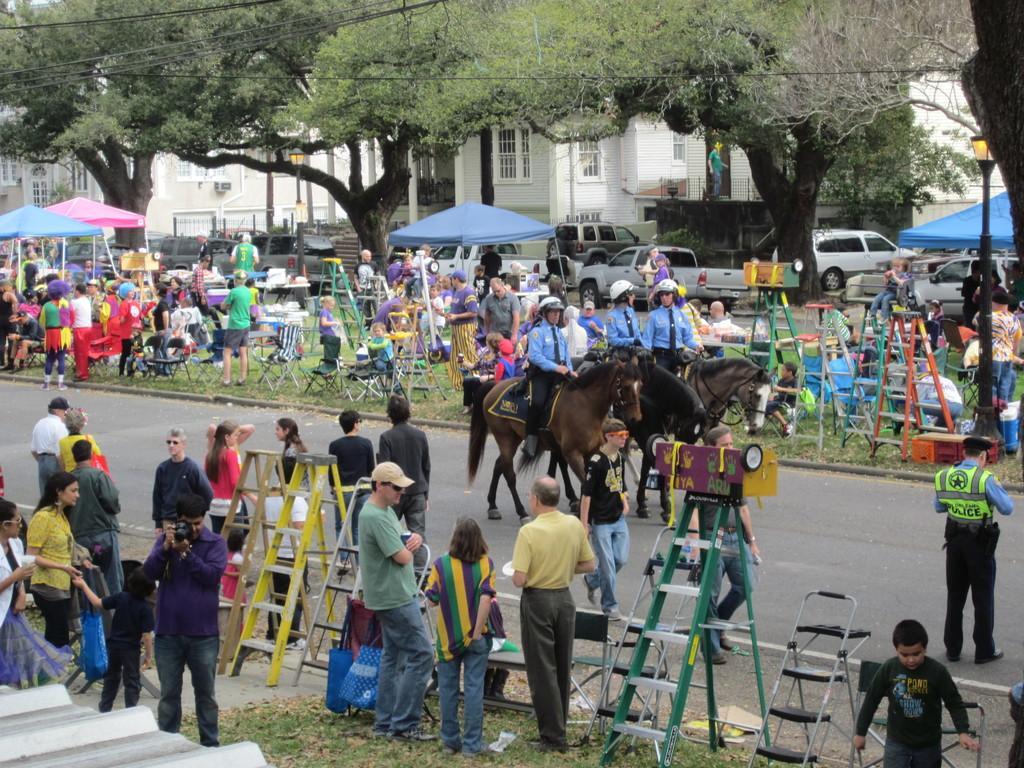Please provide a concise description of this image. This picture is taken beside the road. On the road there are three people riding on the three horses. All of them are wearing blue shirts and white helmets. On either side of the road there are people, ladders and other objects. Towards the right, there is a man in green jacket. On the top, there are umbrellas, buildings, vehicles and trees. 